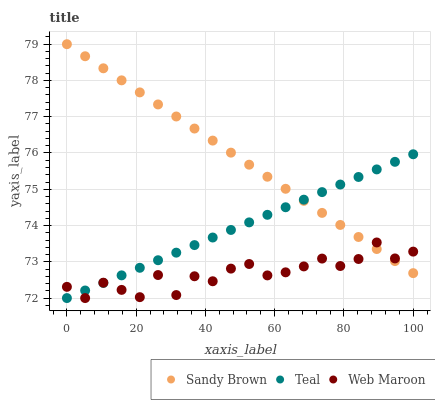Does Web Maroon have the minimum area under the curve?
Answer yes or no. Yes. Does Sandy Brown have the maximum area under the curve?
Answer yes or no. Yes. Does Teal have the minimum area under the curve?
Answer yes or no. No. Does Teal have the maximum area under the curve?
Answer yes or no. No. Is Sandy Brown the smoothest?
Answer yes or no. Yes. Is Web Maroon the roughest?
Answer yes or no. Yes. Is Teal the smoothest?
Answer yes or no. No. Is Teal the roughest?
Answer yes or no. No. Does Web Maroon have the lowest value?
Answer yes or no. Yes. Does Sandy Brown have the lowest value?
Answer yes or no. No. Does Sandy Brown have the highest value?
Answer yes or no. Yes. Does Teal have the highest value?
Answer yes or no. No. Does Sandy Brown intersect Web Maroon?
Answer yes or no. Yes. Is Sandy Brown less than Web Maroon?
Answer yes or no. No. Is Sandy Brown greater than Web Maroon?
Answer yes or no. No. 